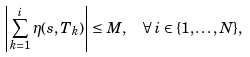Convert formula to latex. <formula><loc_0><loc_0><loc_500><loc_500>\left | \sum _ { k = 1 } ^ { i } \eta ( s , T _ { k } ) \right | \leq M , & \quad \forall \, i \in \{ 1 , \dots , N \} ,</formula> 